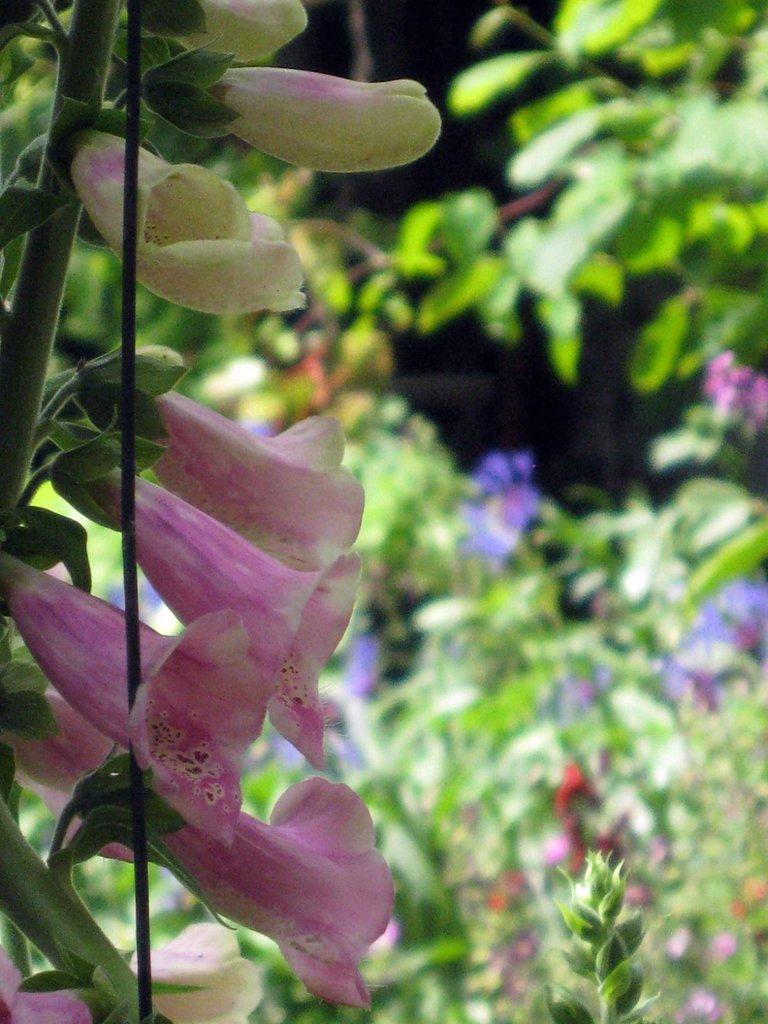How would you summarize this image in a sentence or two? In this image, we can see a flower plant and stick. In the background, we can see the blur view, plants and flowers. 